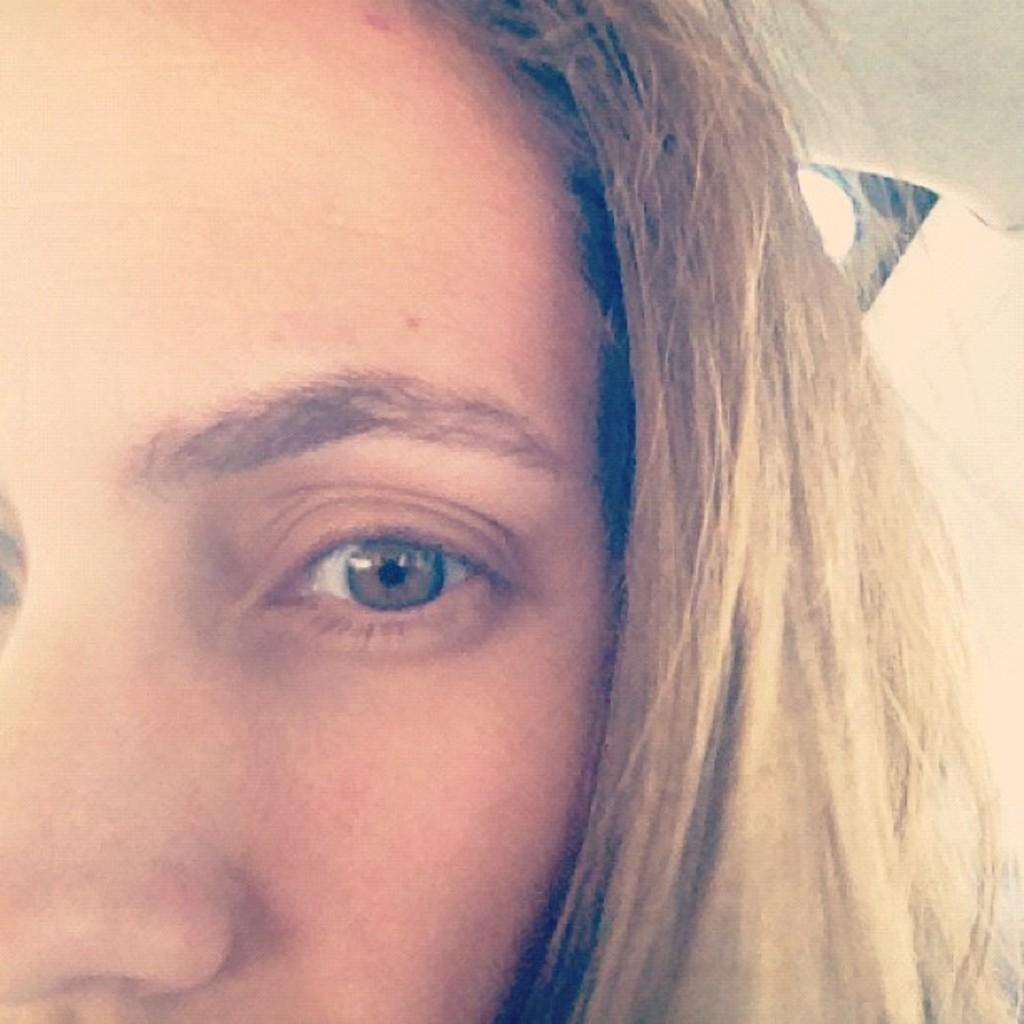What is the main subject of the image? The main subject of the image is a girl's half face. Can you describe the girl's face in the image? Unfortunately, only half of the girl's face is visible in the image. What type of arch can be seen in the background of the image? There is no arch present in the image; it only features a girl's half face. What kind of furniture is visible in the image? There is no furniture visible in the image; it only features a girl's half face. 